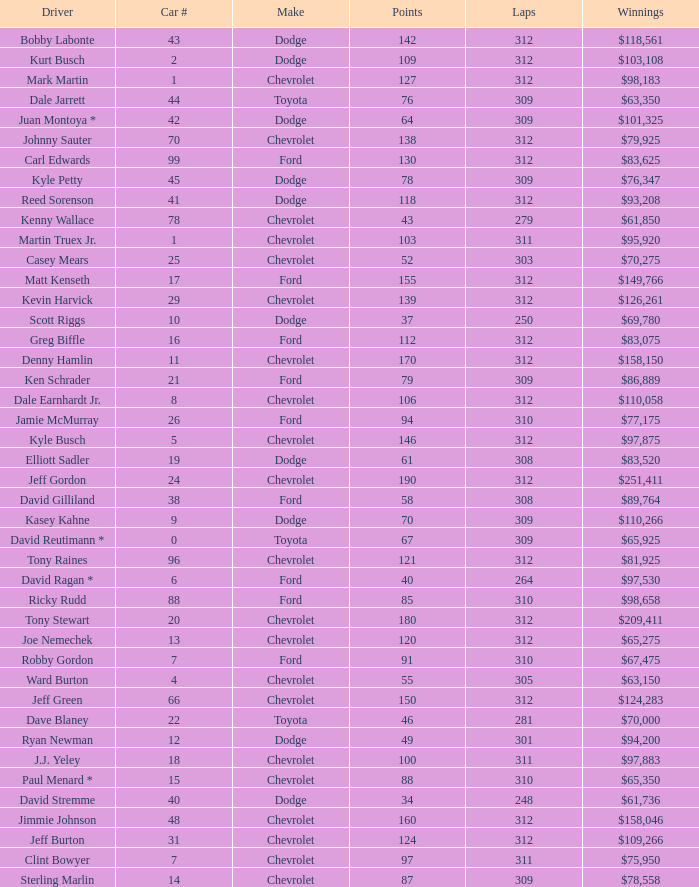What is the lowest number of laps for kyle petty with under 118 points? 309.0. 